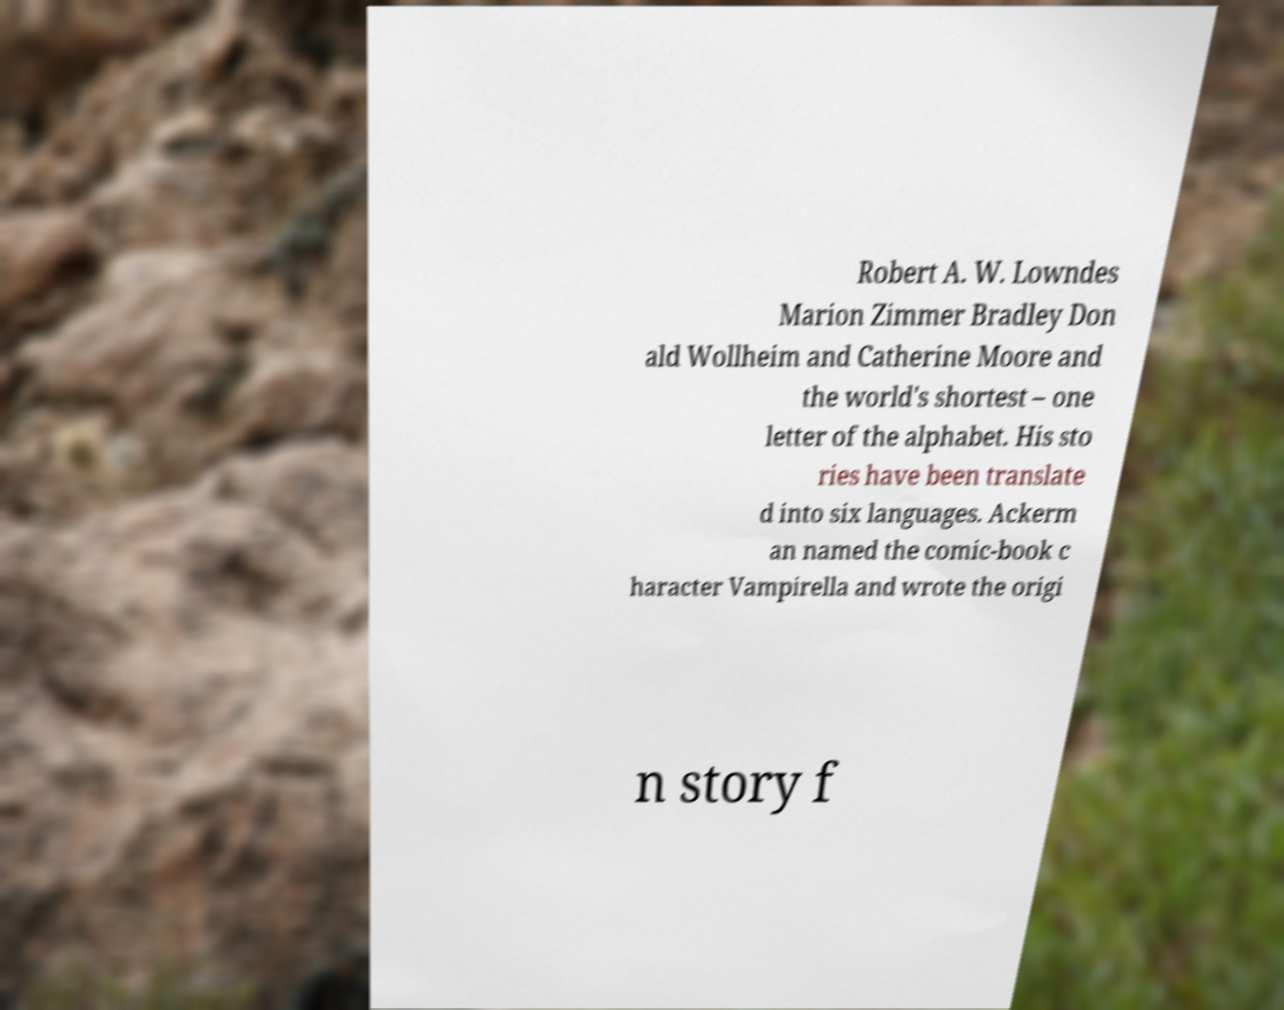Could you assist in decoding the text presented in this image and type it out clearly? Robert A. W. Lowndes Marion Zimmer Bradley Don ald Wollheim and Catherine Moore and the world's shortest – one letter of the alphabet. His sto ries have been translate d into six languages. Ackerm an named the comic-book c haracter Vampirella and wrote the origi n story f 